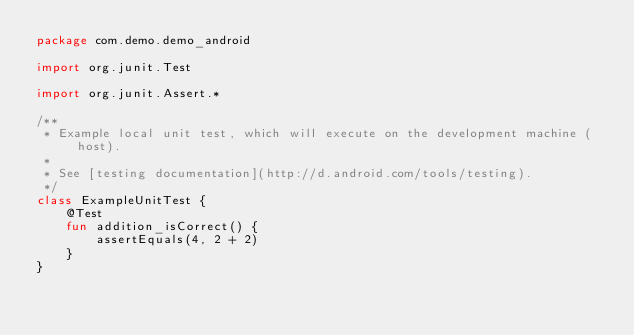<code> <loc_0><loc_0><loc_500><loc_500><_Kotlin_>package com.demo.demo_android

import org.junit.Test

import org.junit.Assert.*

/**
 * Example local unit test, which will execute on the development machine (host).
 *
 * See [testing documentation](http://d.android.com/tools/testing).
 */
class ExampleUnitTest {
    @Test
    fun addition_isCorrect() {
        assertEquals(4, 2 + 2)
    }
}</code> 